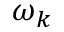<formula> <loc_0><loc_0><loc_500><loc_500>\omega _ { k }</formula> 